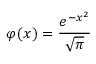Convert formula to latex. <formula><loc_0><loc_0><loc_500><loc_500>\varphi ( x ) = { \frac { e ^ { - x ^ { 2 } } } { \sqrt { \pi } } }</formula> 